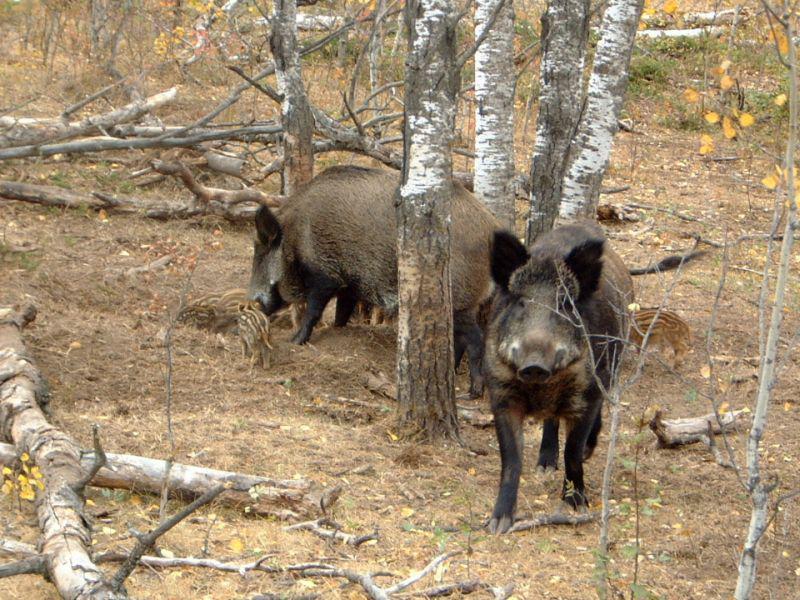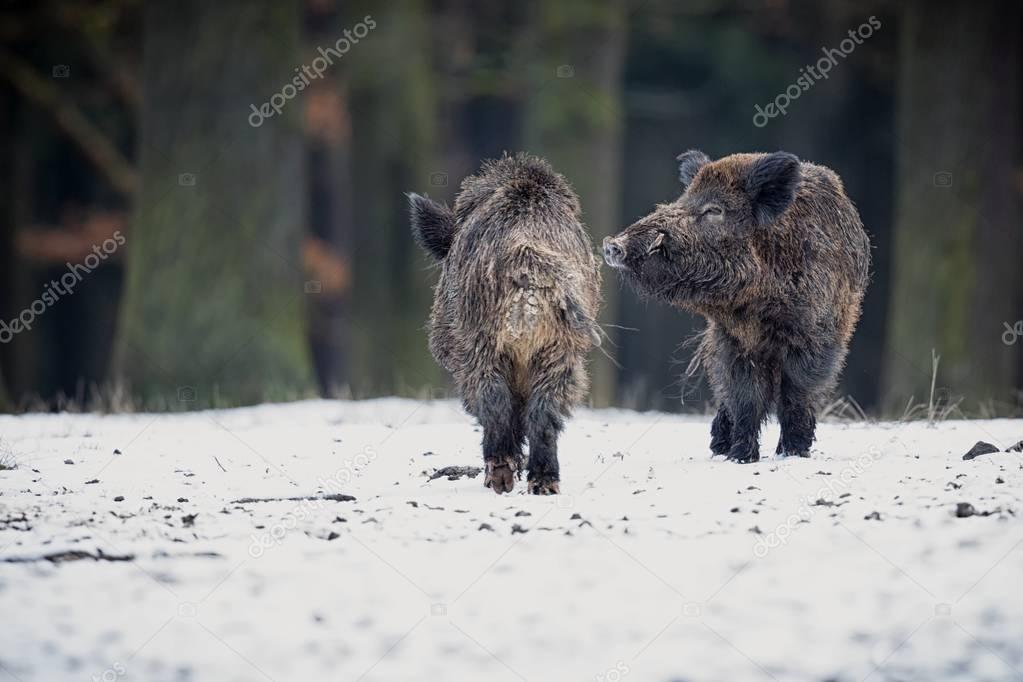The first image is the image on the left, the second image is the image on the right. Given the left and right images, does the statement "There are exactly four pigs." hold true? Answer yes or no. Yes. The first image is the image on the left, the second image is the image on the right. Analyze the images presented: Is the assertion "An image contains at least two baby piglets with distinctive brown and beige striped fur, who are standing on all fours and facing forward." valid? Answer yes or no. No. 